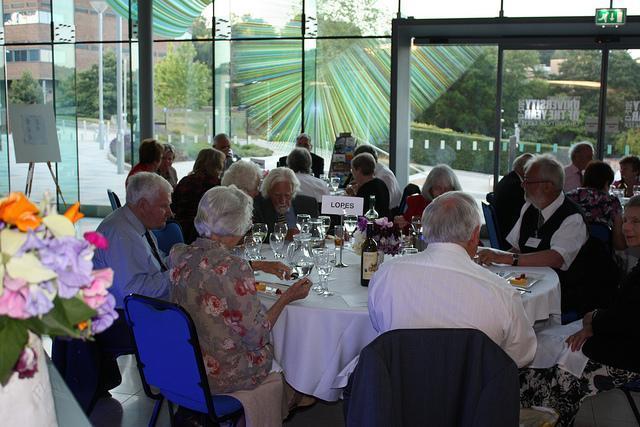How many people are in the photo?
Give a very brief answer. 7. How many chairs are in the picture?
Give a very brief answer. 2. How many black cars are setting near the pillar?
Give a very brief answer. 0. 